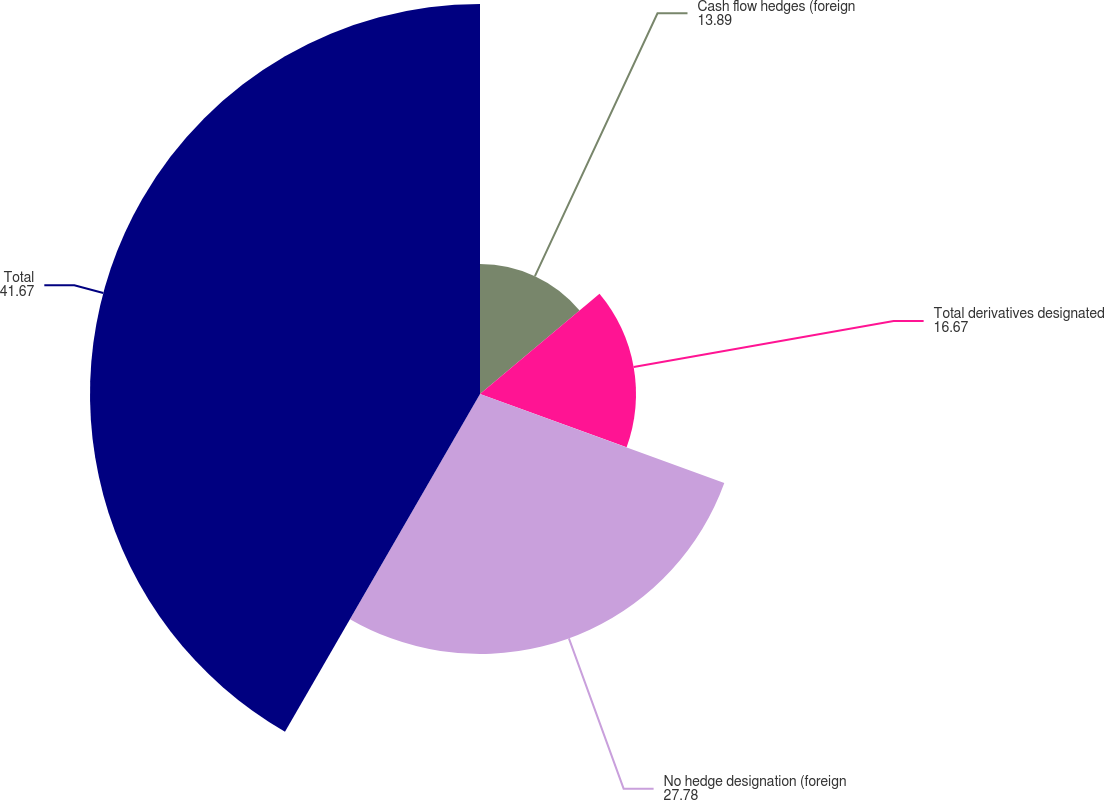Convert chart to OTSL. <chart><loc_0><loc_0><loc_500><loc_500><pie_chart><fcel>Cash flow hedges (foreign<fcel>Total derivatives designated<fcel>No hedge designation (foreign<fcel>Total<nl><fcel>13.89%<fcel>16.67%<fcel>27.78%<fcel>41.67%<nl></chart> 